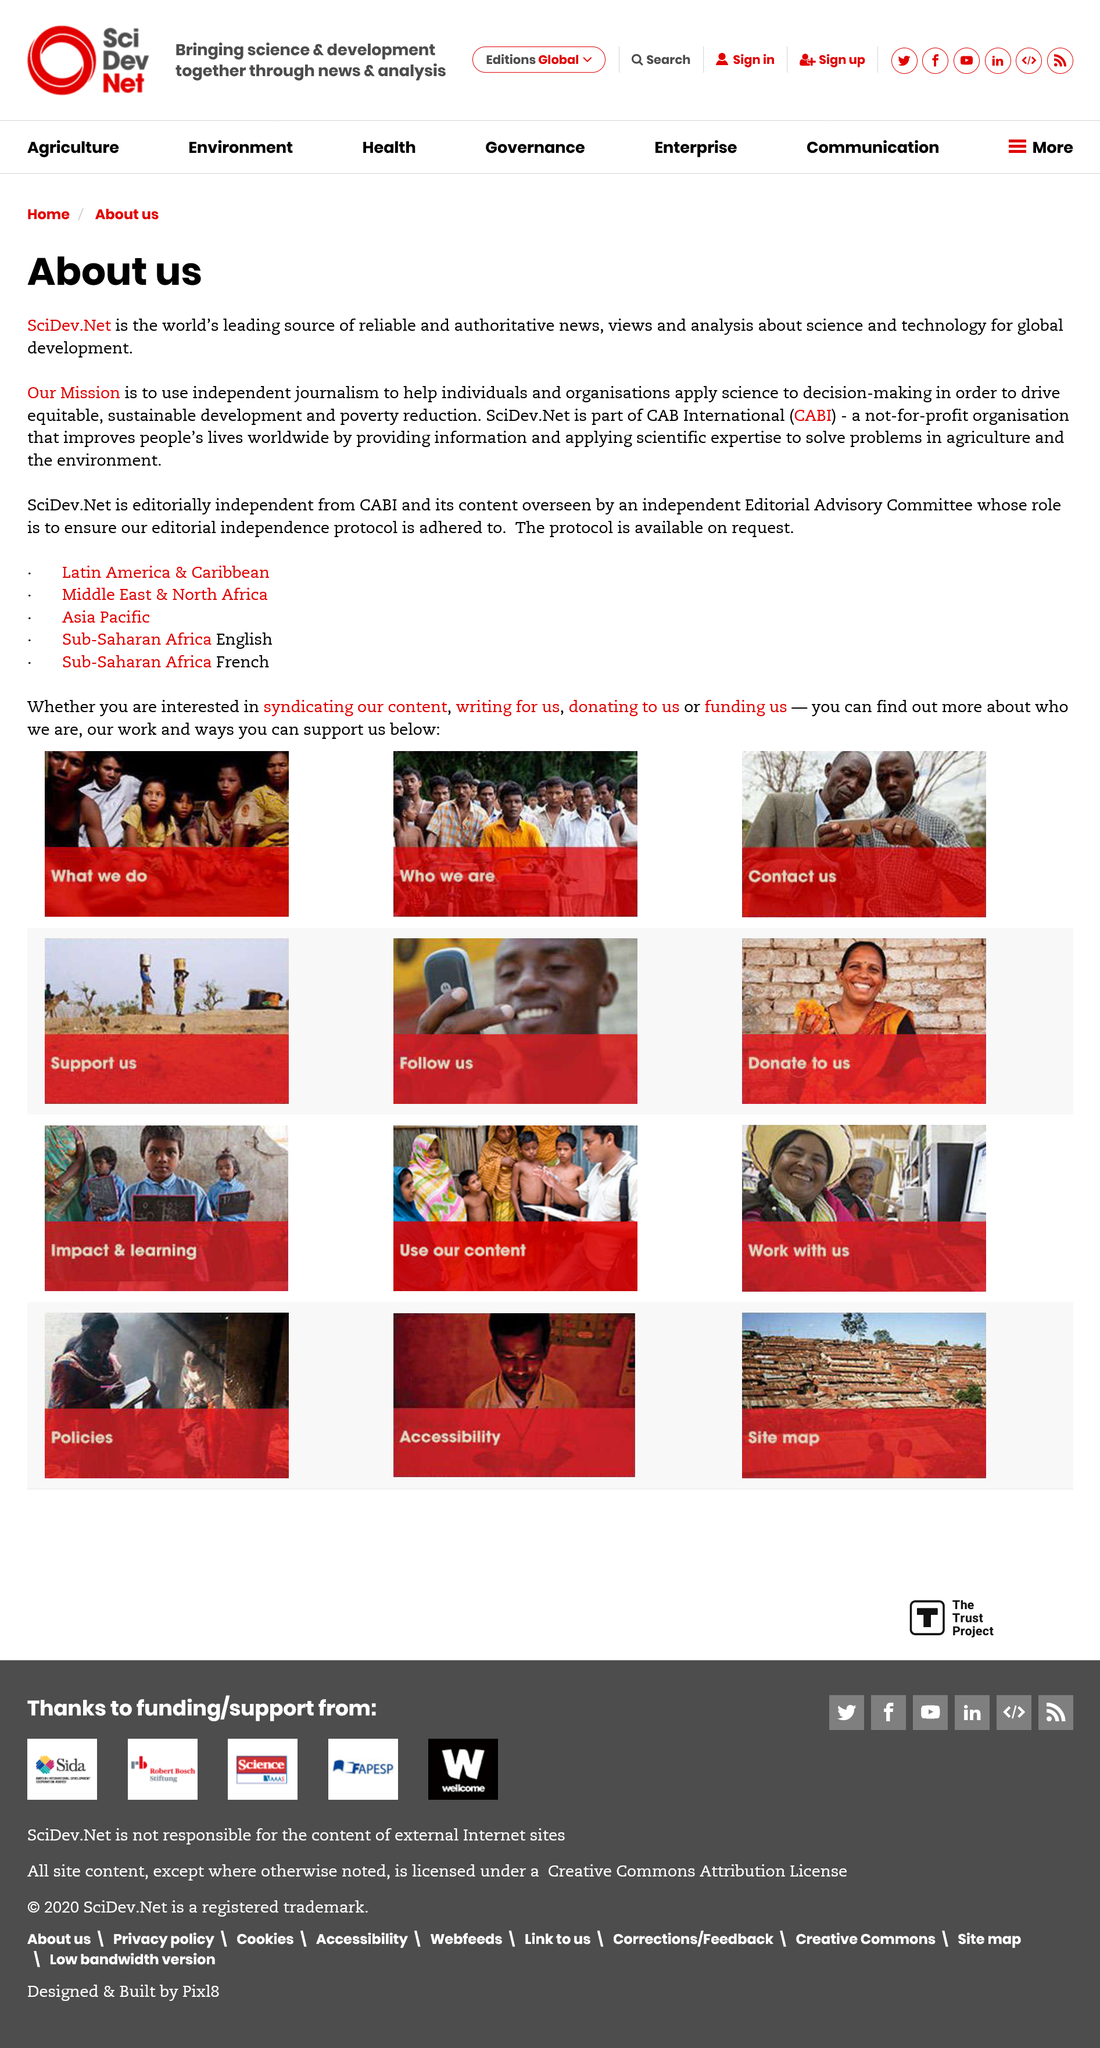Highlight a few significant elements in this photo. CABI stands for CAB International, a well-known acronym that is widely recognized in the field of agricultural research and development. SciDev.Net is a not-for-profit organization that is editorially independent from CAB International. CAB International is part of an entity, and SciDev.Net is part of CAB International. 